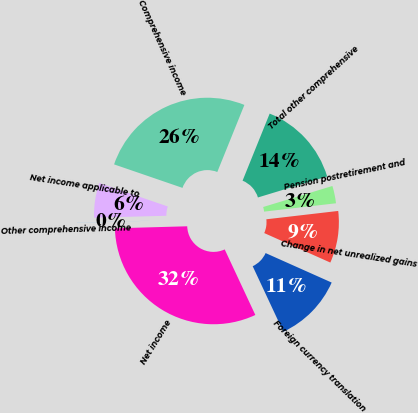<chart> <loc_0><loc_0><loc_500><loc_500><pie_chart><fcel>Net income<fcel>Foreign currency translation<fcel>Change in net unrealized gains<fcel>Pension postretirement and<fcel>Total other comprehensive<fcel>Comprehensive income<fcel>Net income applicable to<fcel>Other comprehensive income<nl><fcel>31.51%<fcel>11.36%<fcel>8.52%<fcel>2.85%<fcel>14.2%<fcel>25.84%<fcel>5.69%<fcel>0.02%<nl></chart> 